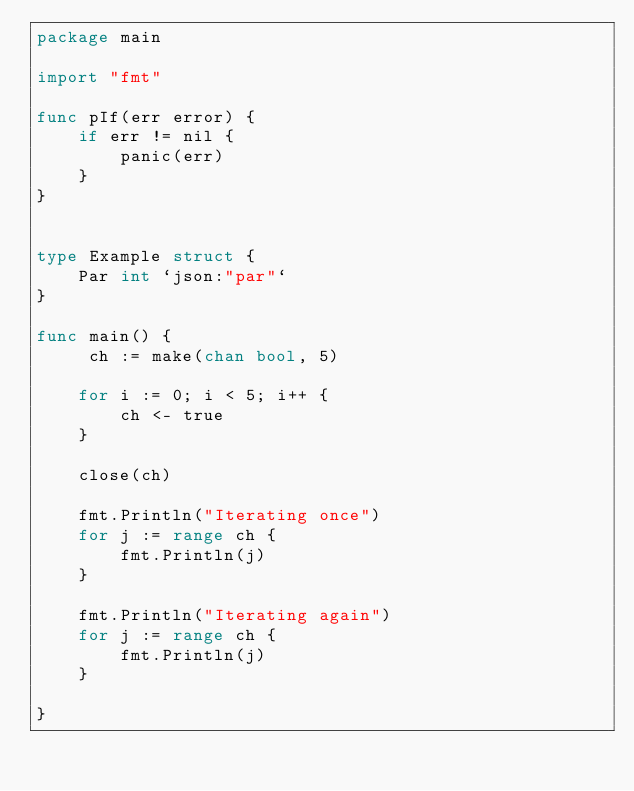<code> <loc_0><loc_0><loc_500><loc_500><_Go_>package main

import "fmt"

func pIf(err error) {
	if err != nil {
		panic(err)
	}
}


type Example struct {
	Par int `json:"par"`
}

func main() {
	 ch := make(chan bool, 5)

	for i := 0; i < 5; i++ {
		ch <- true
	}

	close(ch)

	fmt.Println("Iterating once")
	for j := range ch {
		fmt.Println(j)
	}

	fmt.Println("Iterating again")
	for j := range ch {
		fmt.Println(j)
	}

}
</code> 